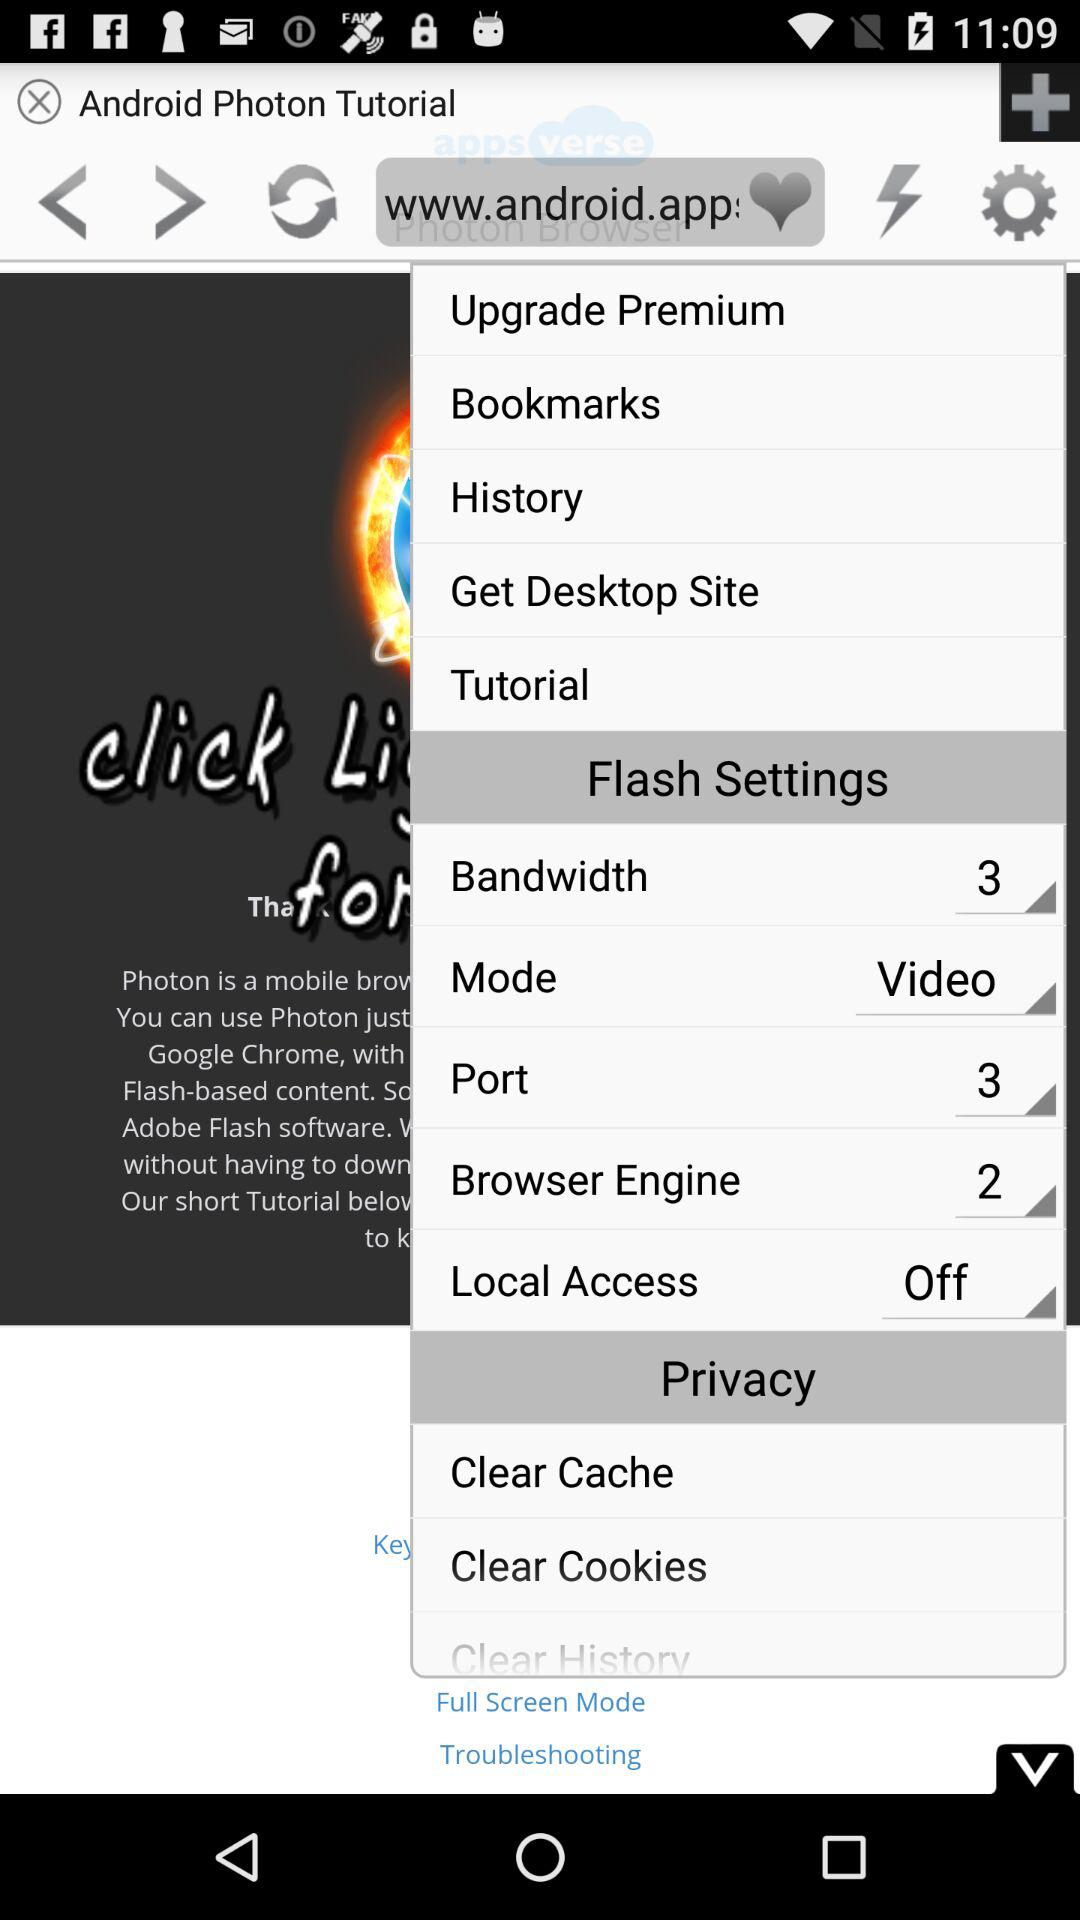How many MBs are in the cache?
When the provided information is insufficient, respond with <no answer>. <no answer> 